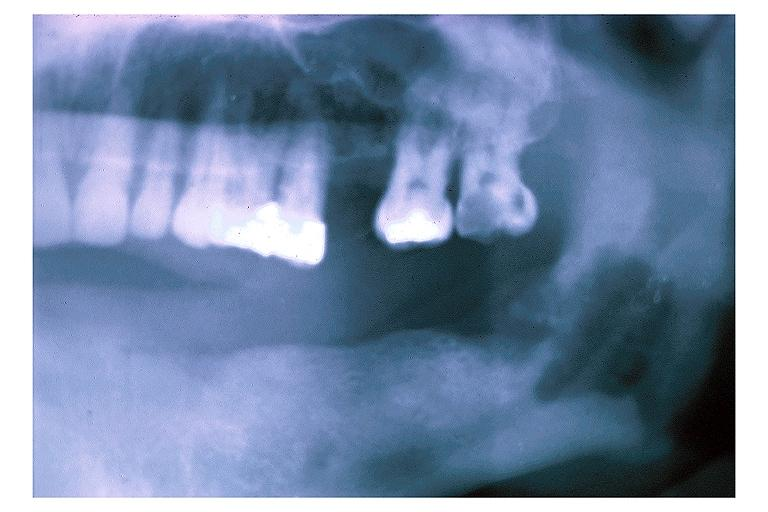what is present?
Answer the question using a single word or phrase. Oral 